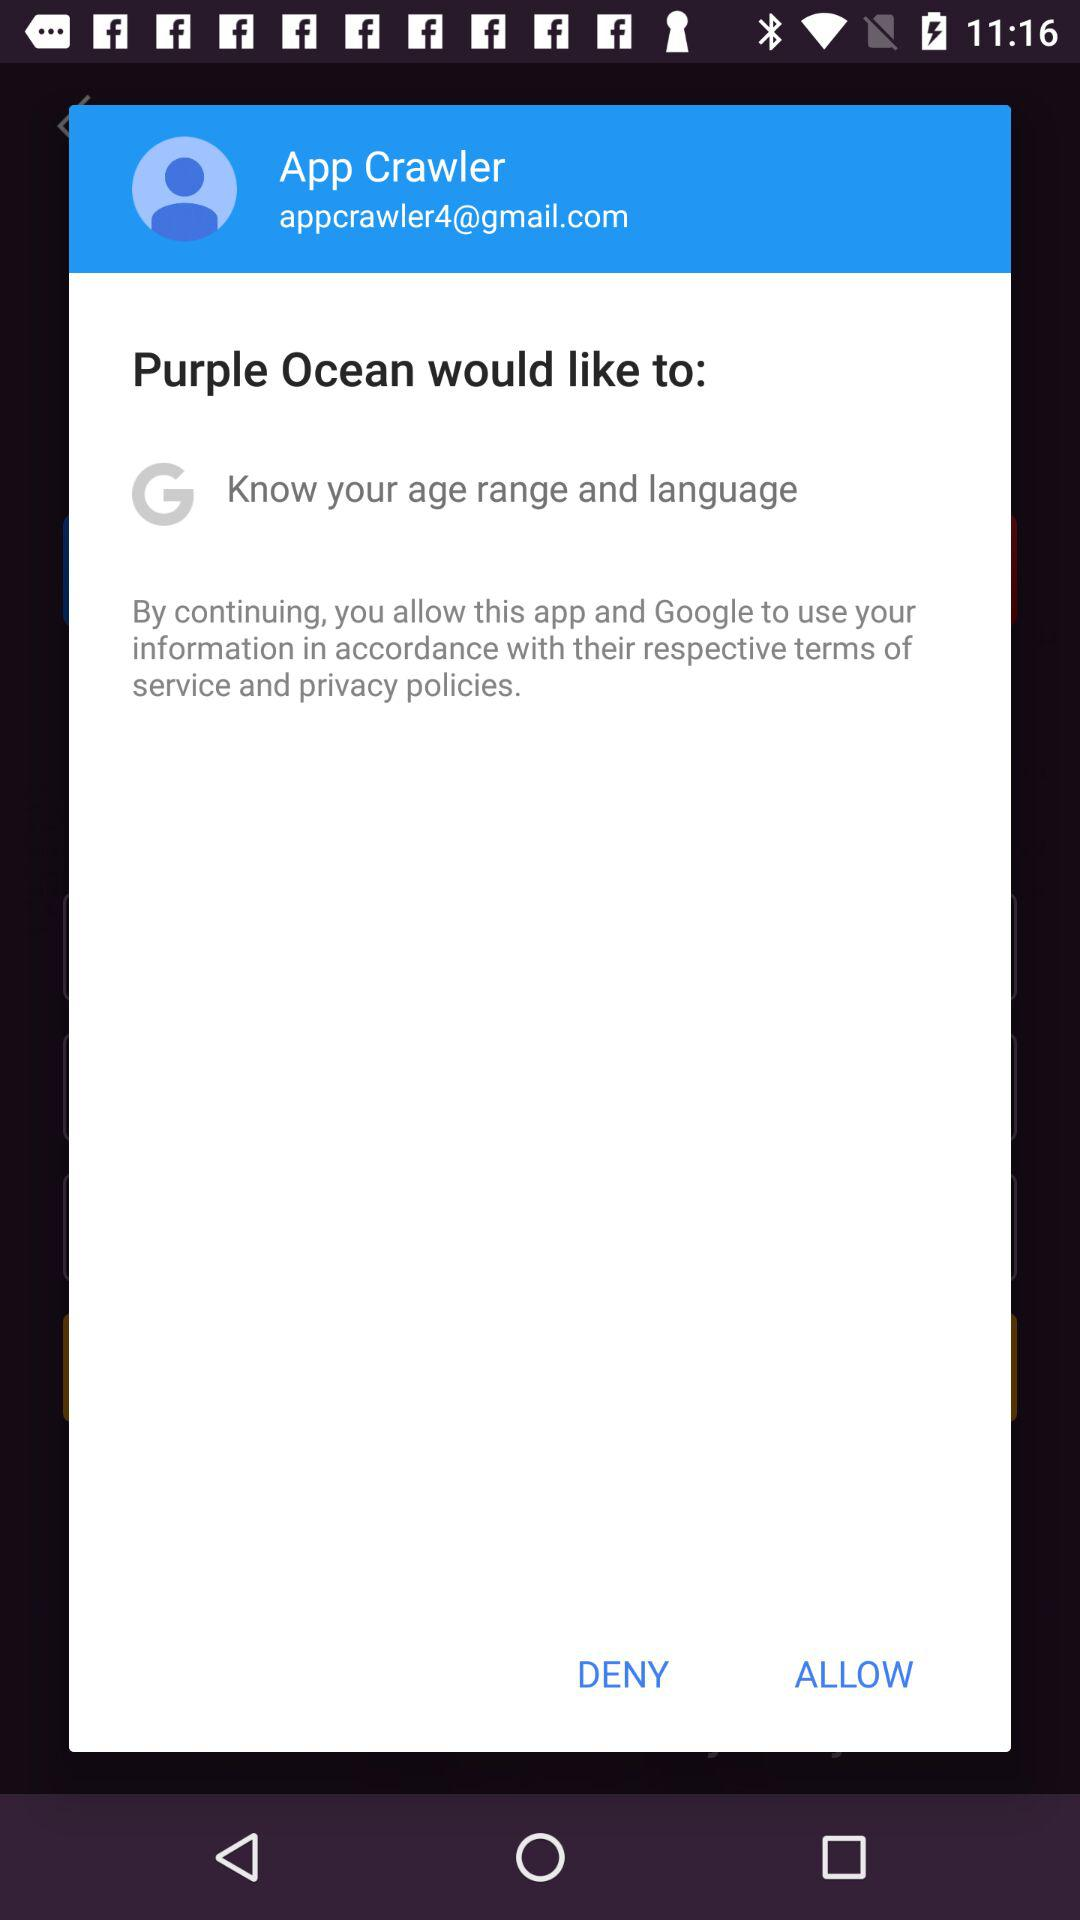What application is asking for permission? The application asking for permission is "Purple Ocean". 